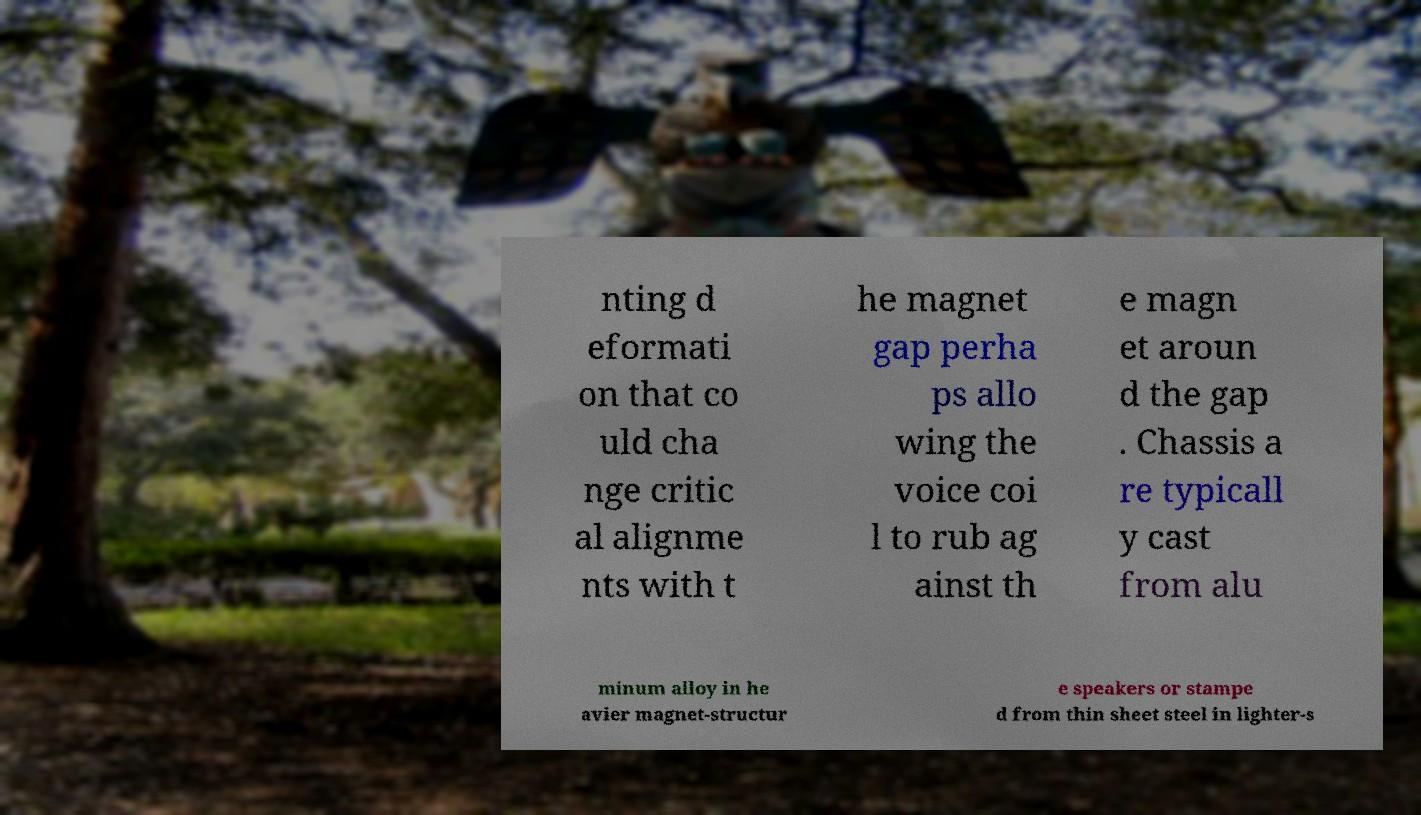Could you assist in decoding the text presented in this image and type it out clearly? nting d eformati on that co uld cha nge critic al alignme nts with t he magnet gap perha ps allo wing the voice coi l to rub ag ainst th e magn et aroun d the gap . Chassis a re typicall y cast from alu minum alloy in he avier magnet-structur e speakers or stampe d from thin sheet steel in lighter-s 